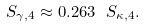<formula> <loc_0><loc_0><loc_500><loc_500>S _ { \gamma , 4 } \approx 0 . 2 6 3 \ S _ { \kappa , 4 } .</formula> 